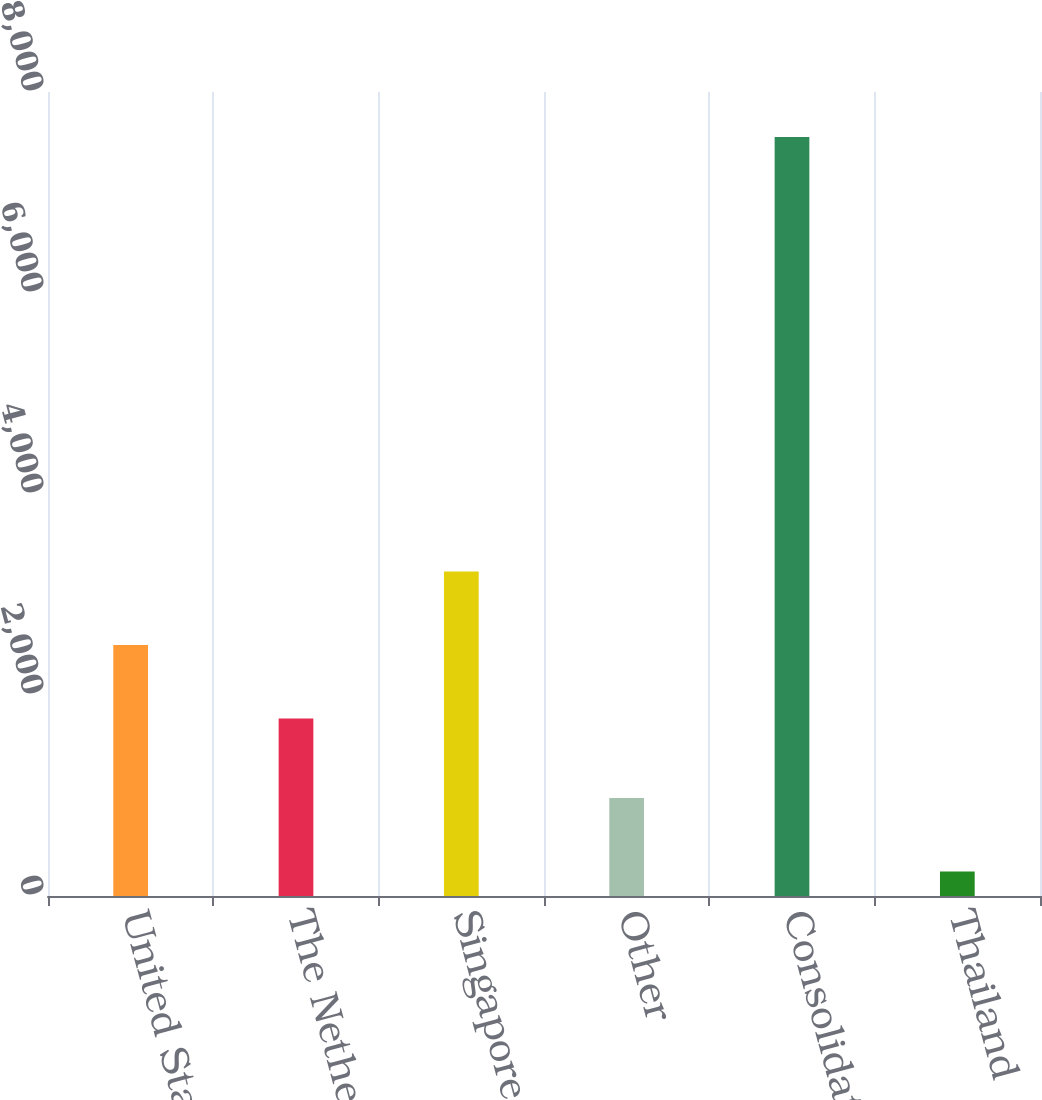Convert chart to OTSL. <chart><loc_0><loc_0><loc_500><loc_500><bar_chart><fcel>United States<fcel>The Netherlands<fcel>Singapore<fcel>Other<fcel>Consolidated<fcel>Thailand<nl><fcel>2498<fcel>1767<fcel>3229<fcel>974<fcel>7553<fcel>243<nl></chart> 